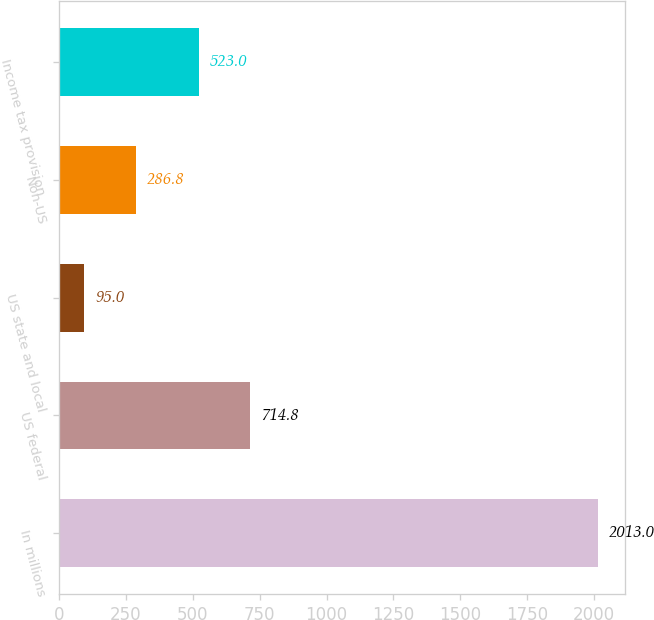<chart> <loc_0><loc_0><loc_500><loc_500><bar_chart><fcel>In millions<fcel>US federal<fcel>US state and local<fcel>Non-US<fcel>Income tax provision<nl><fcel>2013<fcel>714.8<fcel>95<fcel>286.8<fcel>523<nl></chart> 